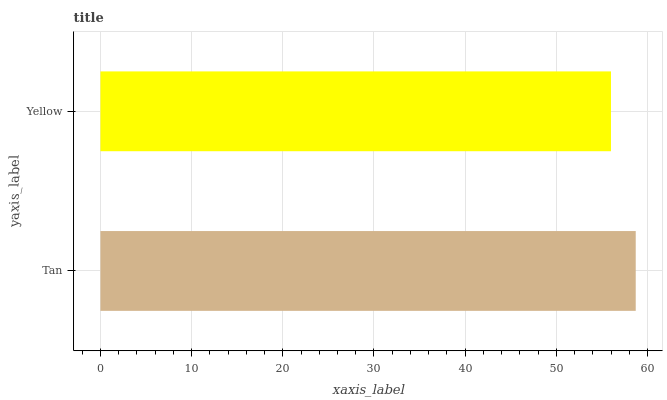Is Yellow the minimum?
Answer yes or no. Yes. Is Tan the maximum?
Answer yes or no. Yes. Is Yellow the maximum?
Answer yes or no. No. Is Tan greater than Yellow?
Answer yes or no. Yes. Is Yellow less than Tan?
Answer yes or no. Yes. Is Yellow greater than Tan?
Answer yes or no. No. Is Tan less than Yellow?
Answer yes or no. No. Is Tan the high median?
Answer yes or no. Yes. Is Yellow the low median?
Answer yes or no. Yes. Is Yellow the high median?
Answer yes or no. No. Is Tan the low median?
Answer yes or no. No. 